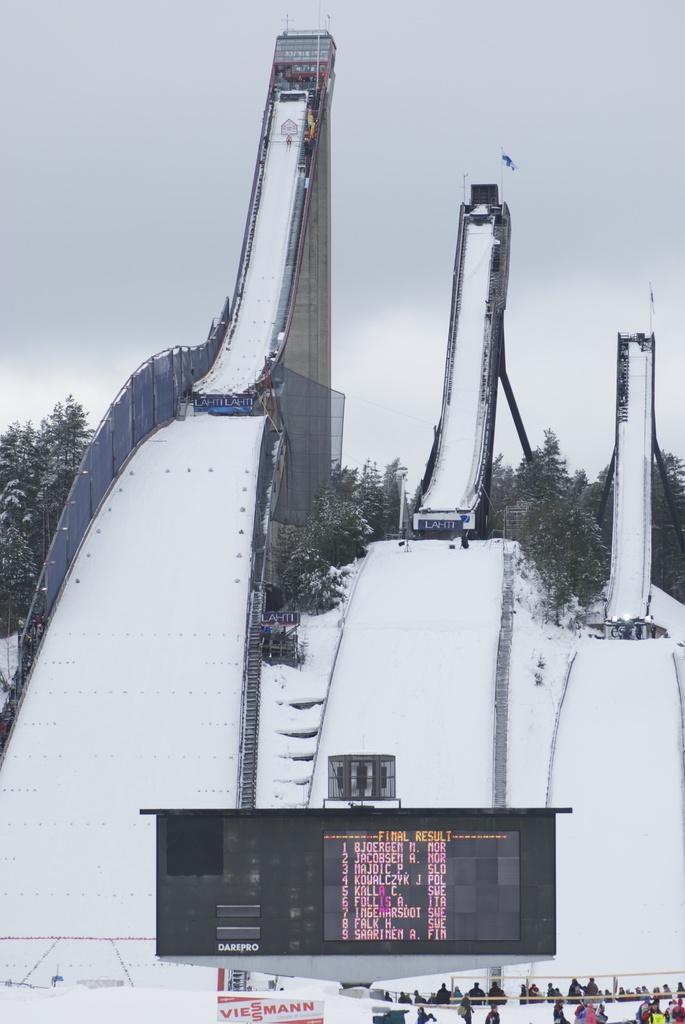Can you describe this image briefly? In this image I can see the slides covered with the snow. In-front of the slides I can see the screen, boards and the people with different color dresses. In the background there are many trees and the sky. 